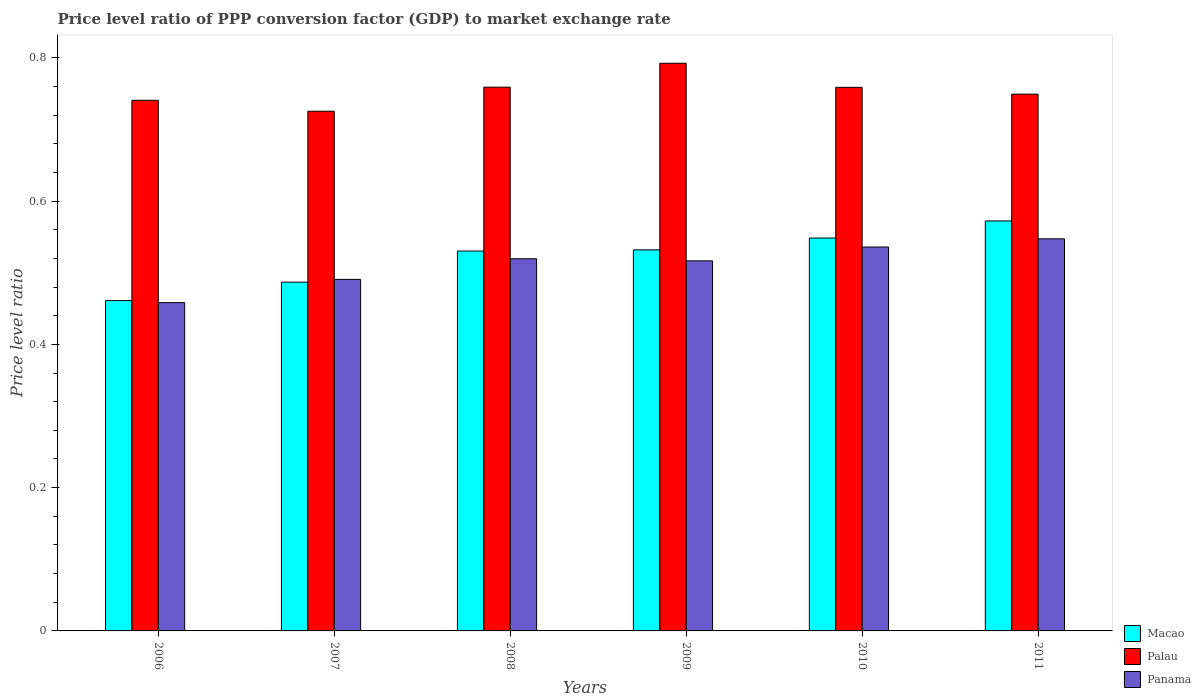Are the number of bars on each tick of the X-axis equal?
Keep it short and to the point. Yes. How many bars are there on the 5th tick from the left?
Your response must be concise. 3. How many bars are there on the 1st tick from the right?
Make the answer very short. 3. In how many cases, is the number of bars for a given year not equal to the number of legend labels?
Your answer should be compact. 0. What is the price level ratio in Palau in 2008?
Offer a very short reply. 0.76. Across all years, what is the maximum price level ratio in Palau?
Your answer should be very brief. 0.79. Across all years, what is the minimum price level ratio in Palau?
Make the answer very short. 0.73. In which year was the price level ratio in Macao minimum?
Provide a succinct answer. 2006. What is the total price level ratio in Panama in the graph?
Provide a short and direct response. 3.07. What is the difference between the price level ratio in Palau in 2009 and that in 2011?
Your response must be concise. 0.04. What is the difference between the price level ratio in Palau in 2008 and the price level ratio in Panama in 2010?
Keep it short and to the point. 0.22. What is the average price level ratio in Palau per year?
Ensure brevity in your answer.  0.75. In the year 2011, what is the difference between the price level ratio in Panama and price level ratio in Palau?
Your response must be concise. -0.2. What is the ratio of the price level ratio in Palau in 2006 to that in 2010?
Your answer should be very brief. 0.98. Is the price level ratio in Panama in 2007 less than that in 2011?
Make the answer very short. Yes. Is the difference between the price level ratio in Panama in 2007 and 2009 greater than the difference between the price level ratio in Palau in 2007 and 2009?
Your answer should be very brief. Yes. What is the difference between the highest and the second highest price level ratio in Panama?
Provide a short and direct response. 0.01. What is the difference between the highest and the lowest price level ratio in Panama?
Provide a succinct answer. 0.09. In how many years, is the price level ratio in Palau greater than the average price level ratio in Palau taken over all years?
Keep it short and to the point. 3. What does the 2nd bar from the left in 2010 represents?
Your answer should be compact. Palau. What does the 3rd bar from the right in 2009 represents?
Keep it short and to the point. Macao. Are all the bars in the graph horizontal?
Your answer should be compact. No. What is the difference between two consecutive major ticks on the Y-axis?
Your answer should be compact. 0.2. Are the values on the major ticks of Y-axis written in scientific E-notation?
Your answer should be compact. No. How many legend labels are there?
Your response must be concise. 3. What is the title of the graph?
Make the answer very short. Price level ratio of PPP conversion factor (GDP) to market exchange rate. Does "El Salvador" appear as one of the legend labels in the graph?
Your answer should be very brief. No. What is the label or title of the Y-axis?
Offer a very short reply. Price level ratio. What is the Price level ratio in Macao in 2006?
Offer a very short reply. 0.46. What is the Price level ratio in Palau in 2006?
Make the answer very short. 0.74. What is the Price level ratio of Panama in 2006?
Your response must be concise. 0.46. What is the Price level ratio of Macao in 2007?
Your response must be concise. 0.49. What is the Price level ratio in Palau in 2007?
Offer a very short reply. 0.73. What is the Price level ratio in Panama in 2007?
Provide a short and direct response. 0.49. What is the Price level ratio of Macao in 2008?
Make the answer very short. 0.53. What is the Price level ratio in Palau in 2008?
Ensure brevity in your answer.  0.76. What is the Price level ratio of Panama in 2008?
Your response must be concise. 0.52. What is the Price level ratio in Macao in 2009?
Ensure brevity in your answer.  0.53. What is the Price level ratio in Palau in 2009?
Offer a terse response. 0.79. What is the Price level ratio of Panama in 2009?
Give a very brief answer. 0.52. What is the Price level ratio in Macao in 2010?
Make the answer very short. 0.55. What is the Price level ratio of Palau in 2010?
Keep it short and to the point. 0.76. What is the Price level ratio in Panama in 2010?
Give a very brief answer. 0.54. What is the Price level ratio in Macao in 2011?
Your response must be concise. 0.57. What is the Price level ratio in Palau in 2011?
Your answer should be very brief. 0.75. What is the Price level ratio in Panama in 2011?
Provide a succinct answer. 0.55. Across all years, what is the maximum Price level ratio in Macao?
Ensure brevity in your answer.  0.57. Across all years, what is the maximum Price level ratio of Palau?
Keep it short and to the point. 0.79. Across all years, what is the maximum Price level ratio in Panama?
Offer a very short reply. 0.55. Across all years, what is the minimum Price level ratio in Macao?
Offer a very short reply. 0.46. Across all years, what is the minimum Price level ratio of Palau?
Ensure brevity in your answer.  0.73. Across all years, what is the minimum Price level ratio of Panama?
Offer a terse response. 0.46. What is the total Price level ratio in Macao in the graph?
Ensure brevity in your answer.  3.13. What is the total Price level ratio of Palau in the graph?
Provide a succinct answer. 4.53. What is the total Price level ratio in Panama in the graph?
Ensure brevity in your answer.  3.07. What is the difference between the Price level ratio in Macao in 2006 and that in 2007?
Provide a short and direct response. -0.03. What is the difference between the Price level ratio in Palau in 2006 and that in 2007?
Make the answer very short. 0.02. What is the difference between the Price level ratio in Panama in 2006 and that in 2007?
Keep it short and to the point. -0.03. What is the difference between the Price level ratio of Macao in 2006 and that in 2008?
Provide a succinct answer. -0.07. What is the difference between the Price level ratio in Palau in 2006 and that in 2008?
Your answer should be compact. -0.02. What is the difference between the Price level ratio of Panama in 2006 and that in 2008?
Offer a very short reply. -0.06. What is the difference between the Price level ratio of Macao in 2006 and that in 2009?
Provide a short and direct response. -0.07. What is the difference between the Price level ratio in Palau in 2006 and that in 2009?
Offer a very short reply. -0.05. What is the difference between the Price level ratio of Panama in 2006 and that in 2009?
Ensure brevity in your answer.  -0.06. What is the difference between the Price level ratio of Macao in 2006 and that in 2010?
Keep it short and to the point. -0.09. What is the difference between the Price level ratio in Palau in 2006 and that in 2010?
Your answer should be compact. -0.02. What is the difference between the Price level ratio of Panama in 2006 and that in 2010?
Your answer should be compact. -0.08. What is the difference between the Price level ratio in Macao in 2006 and that in 2011?
Offer a terse response. -0.11. What is the difference between the Price level ratio in Palau in 2006 and that in 2011?
Make the answer very short. -0.01. What is the difference between the Price level ratio in Panama in 2006 and that in 2011?
Provide a succinct answer. -0.09. What is the difference between the Price level ratio of Macao in 2007 and that in 2008?
Your answer should be compact. -0.04. What is the difference between the Price level ratio of Palau in 2007 and that in 2008?
Ensure brevity in your answer.  -0.03. What is the difference between the Price level ratio in Panama in 2007 and that in 2008?
Offer a very short reply. -0.03. What is the difference between the Price level ratio of Macao in 2007 and that in 2009?
Your answer should be compact. -0.05. What is the difference between the Price level ratio of Palau in 2007 and that in 2009?
Your answer should be compact. -0.07. What is the difference between the Price level ratio of Panama in 2007 and that in 2009?
Provide a succinct answer. -0.03. What is the difference between the Price level ratio in Macao in 2007 and that in 2010?
Provide a succinct answer. -0.06. What is the difference between the Price level ratio of Palau in 2007 and that in 2010?
Keep it short and to the point. -0.03. What is the difference between the Price level ratio in Panama in 2007 and that in 2010?
Offer a very short reply. -0.05. What is the difference between the Price level ratio of Macao in 2007 and that in 2011?
Provide a short and direct response. -0.09. What is the difference between the Price level ratio of Palau in 2007 and that in 2011?
Make the answer very short. -0.02. What is the difference between the Price level ratio of Panama in 2007 and that in 2011?
Offer a terse response. -0.06. What is the difference between the Price level ratio of Macao in 2008 and that in 2009?
Ensure brevity in your answer.  -0. What is the difference between the Price level ratio of Palau in 2008 and that in 2009?
Make the answer very short. -0.03. What is the difference between the Price level ratio in Panama in 2008 and that in 2009?
Give a very brief answer. 0. What is the difference between the Price level ratio in Macao in 2008 and that in 2010?
Your response must be concise. -0.02. What is the difference between the Price level ratio in Panama in 2008 and that in 2010?
Provide a succinct answer. -0.02. What is the difference between the Price level ratio in Macao in 2008 and that in 2011?
Give a very brief answer. -0.04. What is the difference between the Price level ratio of Palau in 2008 and that in 2011?
Make the answer very short. 0.01. What is the difference between the Price level ratio of Panama in 2008 and that in 2011?
Your response must be concise. -0.03. What is the difference between the Price level ratio in Macao in 2009 and that in 2010?
Your answer should be compact. -0.02. What is the difference between the Price level ratio in Palau in 2009 and that in 2010?
Ensure brevity in your answer.  0.03. What is the difference between the Price level ratio in Panama in 2009 and that in 2010?
Your answer should be very brief. -0.02. What is the difference between the Price level ratio of Macao in 2009 and that in 2011?
Provide a succinct answer. -0.04. What is the difference between the Price level ratio in Palau in 2009 and that in 2011?
Offer a terse response. 0.04. What is the difference between the Price level ratio in Panama in 2009 and that in 2011?
Give a very brief answer. -0.03. What is the difference between the Price level ratio of Macao in 2010 and that in 2011?
Offer a terse response. -0.02. What is the difference between the Price level ratio of Palau in 2010 and that in 2011?
Provide a short and direct response. 0.01. What is the difference between the Price level ratio in Panama in 2010 and that in 2011?
Provide a succinct answer. -0.01. What is the difference between the Price level ratio in Macao in 2006 and the Price level ratio in Palau in 2007?
Give a very brief answer. -0.26. What is the difference between the Price level ratio of Macao in 2006 and the Price level ratio of Panama in 2007?
Make the answer very short. -0.03. What is the difference between the Price level ratio of Palau in 2006 and the Price level ratio of Panama in 2007?
Provide a succinct answer. 0.25. What is the difference between the Price level ratio in Macao in 2006 and the Price level ratio in Palau in 2008?
Provide a short and direct response. -0.3. What is the difference between the Price level ratio of Macao in 2006 and the Price level ratio of Panama in 2008?
Your answer should be very brief. -0.06. What is the difference between the Price level ratio in Palau in 2006 and the Price level ratio in Panama in 2008?
Your answer should be compact. 0.22. What is the difference between the Price level ratio of Macao in 2006 and the Price level ratio of Palau in 2009?
Offer a very short reply. -0.33. What is the difference between the Price level ratio in Macao in 2006 and the Price level ratio in Panama in 2009?
Offer a very short reply. -0.06. What is the difference between the Price level ratio of Palau in 2006 and the Price level ratio of Panama in 2009?
Provide a short and direct response. 0.22. What is the difference between the Price level ratio in Macao in 2006 and the Price level ratio in Palau in 2010?
Your response must be concise. -0.3. What is the difference between the Price level ratio of Macao in 2006 and the Price level ratio of Panama in 2010?
Provide a succinct answer. -0.07. What is the difference between the Price level ratio in Palau in 2006 and the Price level ratio in Panama in 2010?
Ensure brevity in your answer.  0.2. What is the difference between the Price level ratio of Macao in 2006 and the Price level ratio of Palau in 2011?
Offer a very short reply. -0.29. What is the difference between the Price level ratio of Macao in 2006 and the Price level ratio of Panama in 2011?
Your answer should be very brief. -0.09. What is the difference between the Price level ratio of Palau in 2006 and the Price level ratio of Panama in 2011?
Offer a very short reply. 0.19. What is the difference between the Price level ratio of Macao in 2007 and the Price level ratio of Palau in 2008?
Ensure brevity in your answer.  -0.27. What is the difference between the Price level ratio of Macao in 2007 and the Price level ratio of Panama in 2008?
Your response must be concise. -0.03. What is the difference between the Price level ratio in Palau in 2007 and the Price level ratio in Panama in 2008?
Ensure brevity in your answer.  0.21. What is the difference between the Price level ratio of Macao in 2007 and the Price level ratio of Palau in 2009?
Your response must be concise. -0.31. What is the difference between the Price level ratio of Macao in 2007 and the Price level ratio of Panama in 2009?
Your response must be concise. -0.03. What is the difference between the Price level ratio of Palau in 2007 and the Price level ratio of Panama in 2009?
Keep it short and to the point. 0.21. What is the difference between the Price level ratio in Macao in 2007 and the Price level ratio in Palau in 2010?
Keep it short and to the point. -0.27. What is the difference between the Price level ratio in Macao in 2007 and the Price level ratio in Panama in 2010?
Your answer should be very brief. -0.05. What is the difference between the Price level ratio in Palau in 2007 and the Price level ratio in Panama in 2010?
Your answer should be compact. 0.19. What is the difference between the Price level ratio of Macao in 2007 and the Price level ratio of Palau in 2011?
Keep it short and to the point. -0.26. What is the difference between the Price level ratio in Macao in 2007 and the Price level ratio in Panama in 2011?
Your answer should be compact. -0.06. What is the difference between the Price level ratio of Palau in 2007 and the Price level ratio of Panama in 2011?
Keep it short and to the point. 0.18. What is the difference between the Price level ratio in Macao in 2008 and the Price level ratio in Palau in 2009?
Offer a very short reply. -0.26. What is the difference between the Price level ratio of Macao in 2008 and the Price level ratio of Panama in 2009?
Keep it short and to the point. 0.01. What is the difference between the Price level ratio in Palau in 2008 and the Price level ratio in Panama in 2009?
Make the answer very short. 0.24. What is the difference between the Price level ratio in Macao in 2008 and the Price level ratio in Palau in 2010?
Offer a terse response. -0.23. What is the difference between the Price level ratio of Macao in 2008 and the Price level ratio of Panama in 2010?
Your answer should be very brief. -0.01. What is the difference between the Price level ratio in Palau in 2008 and the Price level ratio in Panama in 2010?
Your answer should be very brief. 0.22. What is the difference between the Price level ratio of Macao in 2008 and the Price level ratio of Palau in 2011?
Offer a terse response. -0.22. What is the difference between the Price level ratio of Macao in 2008 and the Price level ratio of Panama in 2011?
Your answer should be very brief. -0.02. What is the difference between the Price level ratio in Palau in 2008 and the Price level ratio in Panama in 2011?
Provide a short and direct response. 0.21. What is the difference between the Price level ratio in Macao in 2009 and the Price level ratio in Palau in 2010?
Your response must be concise. -0.23. What is the difference between the Price level ratio of Macao in 2009 and the Price level ratio of Panama in 2010?
Make the answer very short. -0. What is the difference between the Price level ratio of Palau in 2009 and the Price level ratio of Panama in 2010?
Offer a very short reply. 0.26. What is the difference between the Price level ratio in Macao in 2009 and the Price level ratio in Palau in 2011?
Offer a terse response. -0.22. What is the difference between the Price level ratio of Macao in 2009 and the Price level ratio of Panama in 2011?
Offer a very short reply. -0.02. What is the difference between the Price level ratio of Palau in 2009 and the Price level ratio of Panama in 2011?
Keep it short and to the point. 0.25. What is the difference between the Price level ratio in Macao in 2010 and the Price level ratio in Palau in 2011?
Your answer should be compact. -0.2. What is the difference between the Price level ratio in Macao in 2010 and the Price level ratio in Panama in 2011?
Provide a short and direct response. 0. What is the difference between the Price level ratio in Palau in 2010 and the Price level ratio in Panama in 2011?
Your response must be concise. 0.21. What is the average Price level ratio of Macao per year?
Make the answer very short. 0.52. What is the average Price level ratio of Palau per year?
Your answer should be compact. 0.75. What is the average Price level ratio of Panama per year?
Provide a short and direct response. 0.51. In the year 2006, what is the difference between the Price level ratio in Macao and Price level ratio in Palau?
Keep it short and to the point. -0.28. In the year 2006, what is the difference between the Price level ratio in Macao and Price level ratio in Panama?
Your answer should be very brief. 0. In the year 2006, what is the difference between the Price level ratio in Palau and Price level ratio in Panama?
Give a very brief answer. 0.28. In the year 2007, what is the difference between the Price level ratio of Macao and Price level ratio of Palau?
Make the answer very short. -0.24. In the year 2007, what is the difference between the Price level ratio in Macao and Price level ratio in Panama?
Your answer should be very brief. -0. In the year 2007, what is the difference between the Price level ratio of Palau and Price level ratio of Panama?
Offer a terse response. 0.23. In the year 2008, what is the difference between the Price level ratio of Macao and Price level ratio of Palau?
Make the answer very short. -0.23. In the year 2008, what is the difference between the Price level ratio of Macao and Price level ratio of Panama?
Your answer should be very brief. 0.01. In the year 2008, what is the difference between the Price level ratio in Palau and Price level ratio in Panama?
Provide a succinct answer. 0.24. In the year 2009, what is the difference between the Price level ratio of Macao and Price level ratio of Palau?
Provide a short and direct response. -0.26. In the year 2009, what is the difference between the Price level ratio of Macao and Price level ratio of Panama?
Provide a short and direct response. 0.02. In the year 2009, what is the difference between the Price level ratio in Palau and Price level ratio in Panama?
Offer a very short reply. 0.28. In the year 2010, what is the difference between the Price level ratio of Macao and Price level ratio of Palau?
Ensure brevity in your answer.  -0.21. In the year 2010, what is the difference between the Price level ratio in Macao and Price level ratio in Panama?
Offer a terse response. 0.01. In the year 2010, what is the difference between the Price level ratio in Palau and Price level ratio in Panama?
Keep it short and to the point. 0.22. In the year 2011, what is the difference between the Price level ratio in Macao and Price level ratio in Palau?
Offer a very short reply. -0.18. In the year 2011, what is the difference between the Price level ratio of Macao and Price level ratio of Panama?
Offer a terse response. 0.03. In the year 2011, what is the difference between the Price level ratio of Palau and Price level ratio of Panama?
Ensure brevity in your answer.  0.2. What is the ratio of the Price level ratio in Macao in 2006 to that in 2007?
Offer a very short reply. 0.95. What is the ratio of the Price level ratio of Palau in 2006 to that in 2007?
Your answer should be compact. 1.02. What is the ratio of the Price level ratio of Panama in 2006 to that in 2007?
Provide a succinct answer. 0.93. What is the ratio of the Price level ratio in Macao in 2006 to that in 2008?
Your response must be concise. 0.87. What is the ratio of the Price level ratio in Palau in 2006 to that in 2008?
Your answer should be compact. 0.98. What is the ratio of the Price level ratio of Panama in 2006 to that in 2008?
Keep it short and to the point. 0.88. What is the ratio of the Price level ratio in Macao in 2006 to that in 2009?
Offer a very short reply. 0.87. What is the ratio of the Price level ratio of Palau in 2006 to that in 2009?
Provide a short and direct response. 0.93. What is the ratio of the Price level ratio of Panama in 2006 to that in 2009?
Offer a very short reply. 0.89. What is the ratio of the Price level ratio in Macao in 2006 to that in 2010?
Provide a succinct answer. 0.84. What is the ratio of the Price level ratio of Palau in 2006 to that in 2010?
Provide a succinct answer. 0.98. What is the ratio of the Price level ratio in Panama in 2006 to that in 2010?
Provide a short and direct response. 0.86. What is the ratio of the Price level ratio of Macao in 2006 to that in 2011?
Provide a succinct answer. 0.81. What is the ratio of the Price level ratio of Panama in 2006 to that in 2011?
Offer a very short reply. 0.84. What is the ratio of the Price level ratio of Macao in 2007 to that in 2008?
Make the answer very short. 0.92. What is the ratio of the Price level ratio of Palau in 2007 to that in 2008?
Make the answer very short. 0.96. What is the ratio of the Price level ratio in Panama in 2007 to that in 2008?
Provide a short and direct response. 0.94. What is the ratio of the Price level ratio of Macao in 2007 to that in 2009?
Give a very brief answer. 0.92. What is the ratio of the Price level ratio in Palau in 2007 to that in 2009?
Make the answer very short. 0.92. What is the ratio of the Price level ratio of Panama in 2007 to that in 2009?
Offer a very short reply. 0.95. What is the ratio of the Price level ratio in Macao in 2007 to that in 2010?
Ensure brevity in your answer.  0.89. What is the ratio of the Price level ratio of Palau in 2007 to that in 2010?
Ensure brevity in your answer.  0.96. What is the ratio of the Price level ratio in Panama in 2007 to that in 2010?
Your answer should be compact. 0.92. What is the ratio of the Price level ratio in Macao in 2007 to that in 2011?
Provide a succinct answer. 0.85. What is the ratio of the Price level ratio in Palau in 2007 to that in 2011?
Make the answer very short. 0.97. What is the ratio of the Price level ratio of Panama in 2007 to that in 2011?
Your answer should be compact. 0.9. What is the ratio of the Price level ratio of Macao in 2008 to that in 2009?
Make the answer very short. 1. What is the ratio of the Price level ratio of Palau in 2008 to that in 2009?
Offer a very short reply. 0.96. What is the ratio of the Price level ratio of Panama in 2008 to that in 2009?
Keep it short and to the point. 1.01. What is the ratio of the Price level ratio in Macao in 2008 to that in 2010?
Provide a short and direct response. 0.97. What is the ratio of the Price level ratio of Palau in 2008 to that in 2010?
Offer a terse response. 1. What is the ratio of the Price level ratio in Panama in 2008 to that in 2010?
Ensure brevity in your answer.  0.97. What is the ratio of the Price level ratio of Macao in 2008 to that in 2011?
Offer a terse response. 0.93. What is the ratio of the Price level ratio in Panama in 2008 to that in 2011?
Give a very brief answer. 0.95. What is the ratio of the Price level ratio in Macao in 2009 to that in 2010?
Your answer should be compact. 0.97. What is the ratio of the Price level ratio in Palau in 2009 to that in 2010?
Keep it short and to the point. 1.04. What is the ratio of the Price level ratio of Macao in 2009 to that in 2011?
Ensure brevity in your answer.  0.93. What is the ratio of the Price level ratio of Palau in 2009 to that in 2011?
Offer a very short reply. 1.06. What is the ratio of the Price level ratio of Panama in 2009 to that in 2011?
Keep it short and to the point. 0.94. What is the ratio of the Price level ratio of Palau in 2010 to that in 2011?
Keep it short and to the point. 1.01. What is the ratio of the Price level ratio in Panama in 2010 to that in 2011?
Your response must be concise. 0.98. What is the difference between the highest and the second highest Price level ratio of Macao?
Your answer should be compact. 0.02. What is the difference between the highest and the second highest Price level ratio in Palau?
Keep it short and to the point. 0.03. What is the difference between the highest and the second highest Price level ratio of Panama?
Your answer should be very brief. 0.01. What is the difference between the highest and the lowest Price level ratio of Macao?
Your answer should be very brief. 0.11. What is the difference between the highest and the lowest Price level ratio in Palau?
Offer a very short reply. 0.07. What is the difference between the highest and the lowest Price level ratio of Panama?
Your answer should be compact. 0.09. 